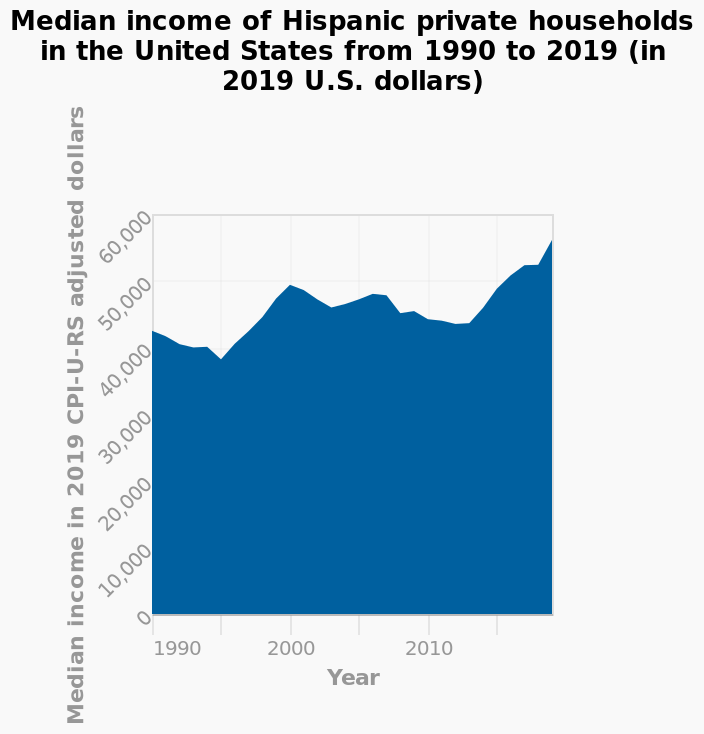<image>
please enumerates aspects of the construction of the chart This area graph is called Median income of Hispanic private households in the United States from 1990 to 2019 (in 2019 U.S. dollars). The x-axis shows Year while the y-axis plots Median income in 2019 CPI-U-RS adjusted dollars. What time period does the graph cover? The graph covers the years from 1990 to 2019. Offer a thorough analysis of the image. The area chart shows in the 1990' the median income in U.s dollars was sitting just over 40,000. This value slowly increased to over 50,000 between 1990 and 2019. 